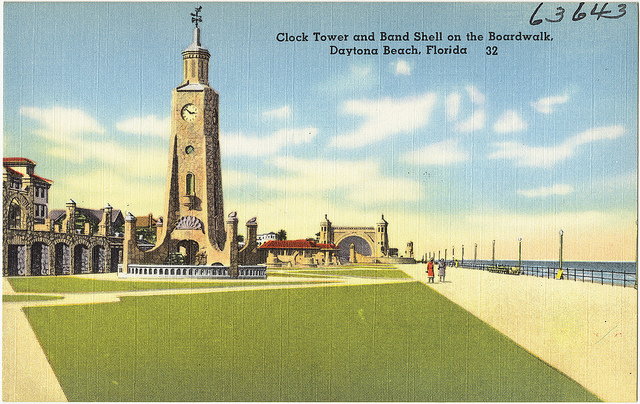Identify the text contained in this image. 63643 Daytona Clock Tower 32 Beach. Florida Boardwalk, the on Shell Band and 